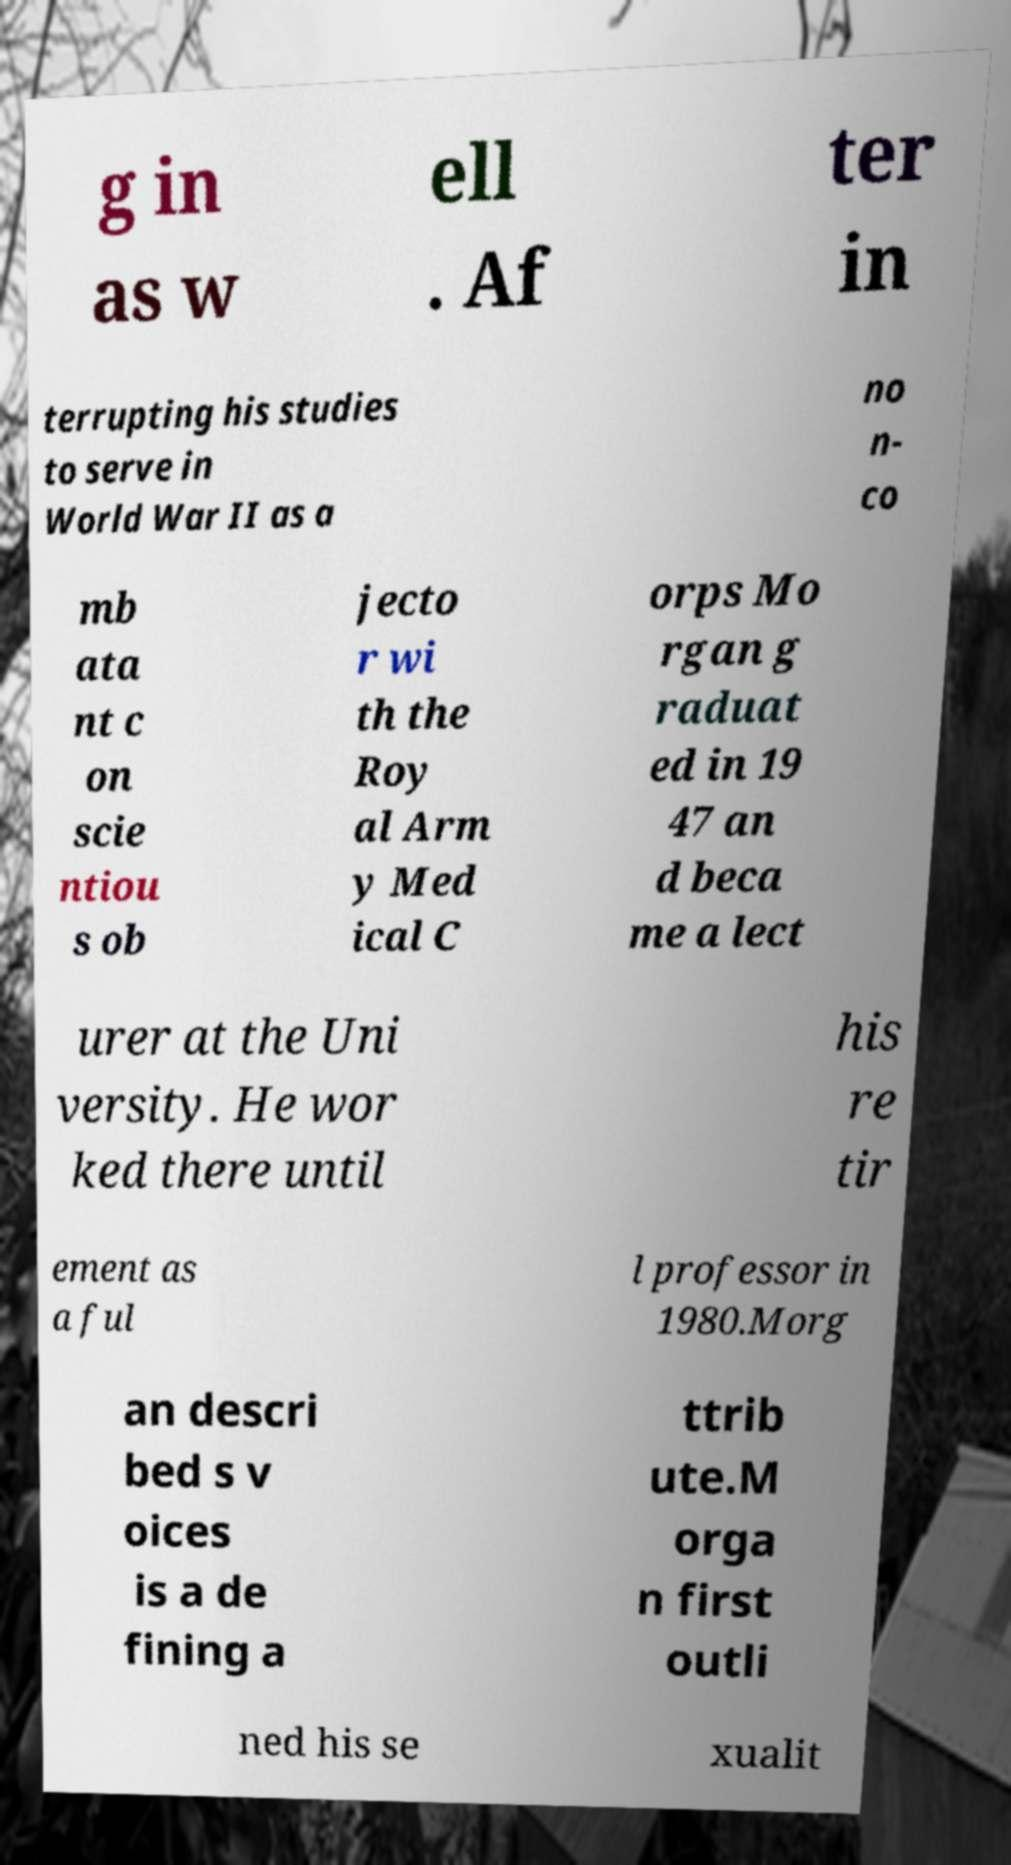I need the written content from this picture converted into text. Can you do that? g in as w ell . Af ter in terrupting his studies to serve in World War II as a no n- co mb ata nt c on scie ntiou s ob jecto r wi th the Roy al Arm y Med ical C orps Mo rgan g raduat ed in 19 47 an d beca me a lect urer at the Uni versity. He wor ked there until his re tir ement as a ful l professor in 1980.Morg an descri bed s v oices is a de fining a ttrib ute.M orga n first outli ned his se xualit 